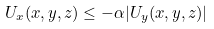<formula> <loc_0><loc_0><loc_500><loc_500>U _ { x } ( x , y , z ) \leq - \alpha | U _ { y } ( x , y , z ) |</formula> 